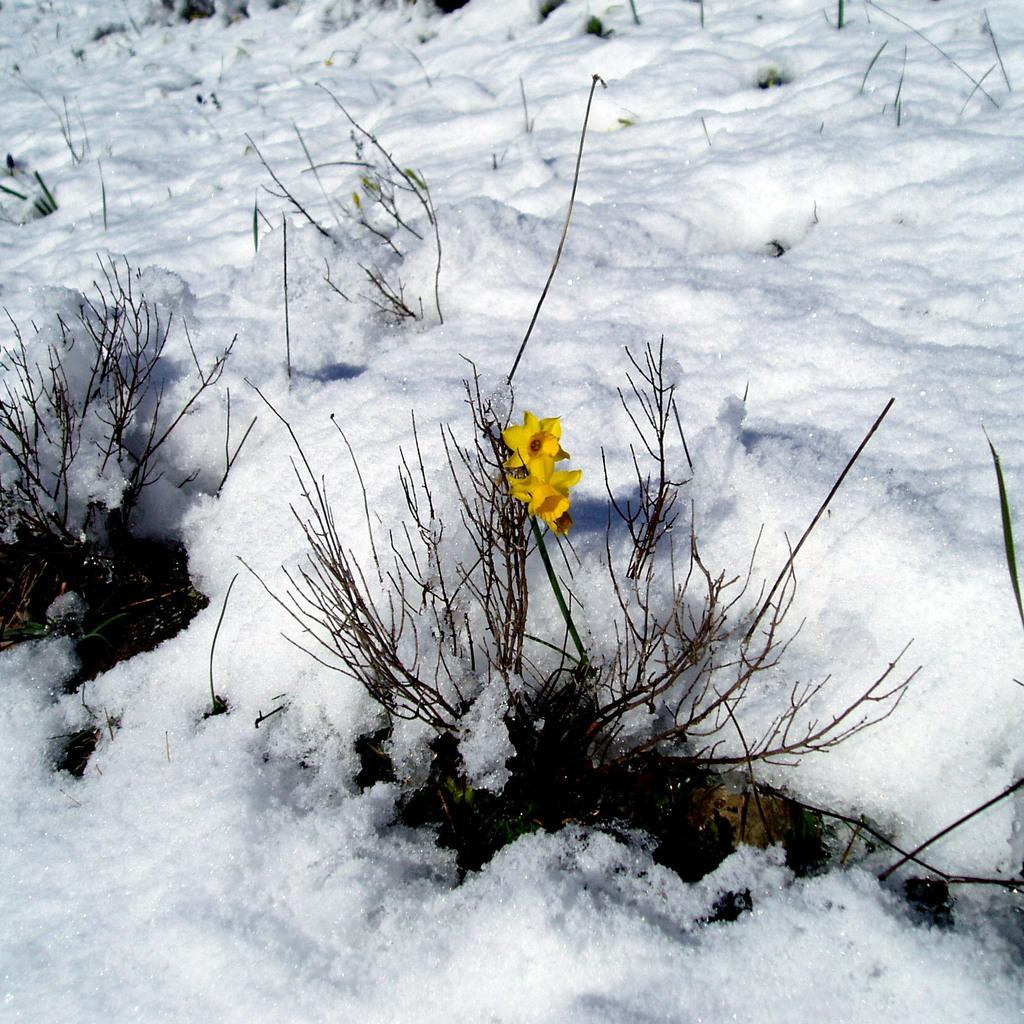How would you summarize this image in a sentence or two? In the image we can see flowers, yellow in color and these are the plants. Everywhere we can see snow, white in color. 